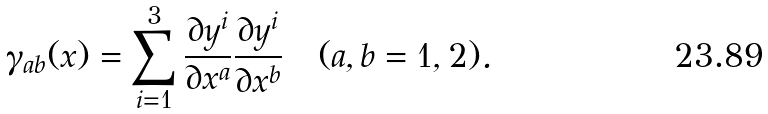<formula> <loc_0><loc_0><loc_500><loc_500>\gamma _ { a b } ( x ) = \sum _ { i = 1 } ^ { 3 } \frac { \partial y ^ { i } } { \partial x ^ { a } } \frac { \partial y ^ { i } } { \partial x ^ { b } } \quad ( a , b = 1 , 2 ) .</formula> 